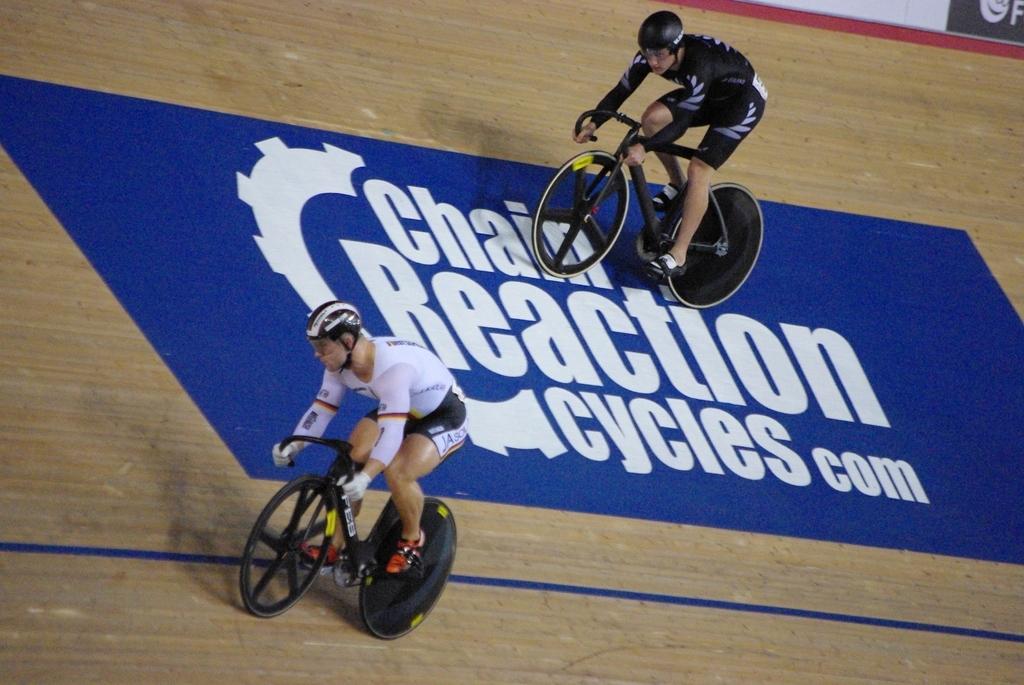<image>
Render a clear and concise summary of the photo. two people are riding bikes over a blue mat on the ground that says Chain Reaction and a website in white letters. 